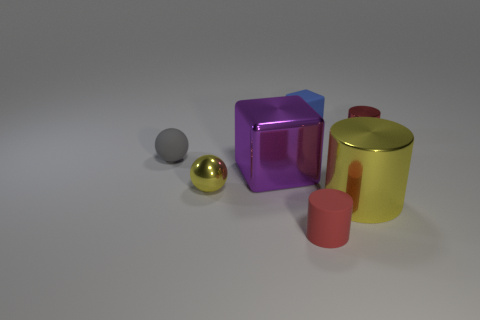Add 3 tiny brown shiny cubes. How many objects exist? 10 Subtract all balls. How many objects are left? 5 Subtract 0 green blocks. How many objects are left? 7 Subtract all small red rubber objects. Subtract all purple shiny objects. How many objects are left? 5 Add 5 small red cylinders. How many small red cylinders are left? 7 Add 7 big yellow metal things. How many big yellow metal things exist? 8 